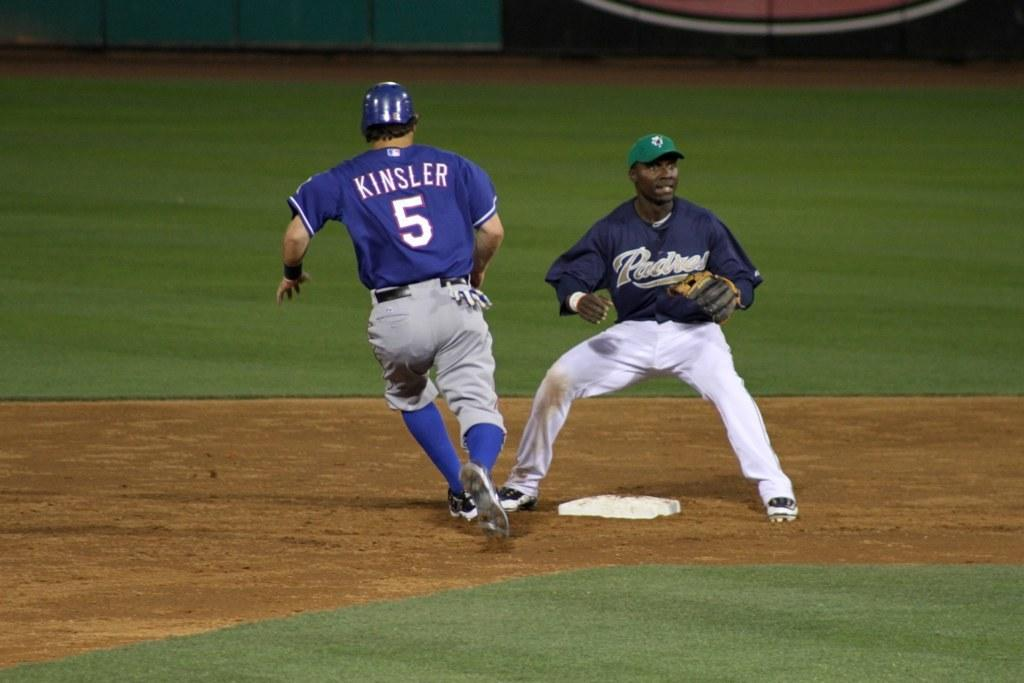<image>
Summarize the visual content of the image. Kinsler in the number 5 jersey appears to be safe. 